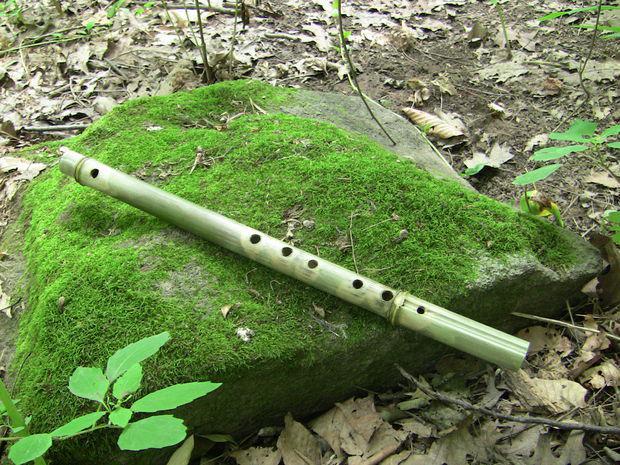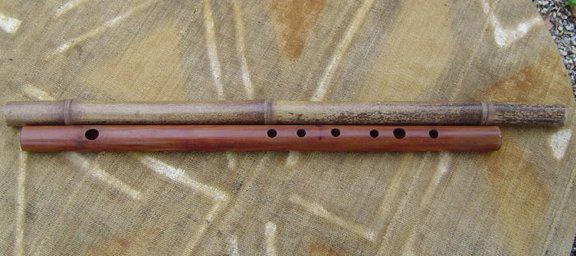The first image is the image on the left, the second image is the image on the right. Given the left and right images, does the statement "There are three flutes in total." hold true? Answer yes or no. Yes. The first image is the image on the left, the second image is the image on the right. For the images displayed, is the sentence "One image contains a single flute displayed diagonally, and the other image contains two items displayed horizontally, at least one a bamboo stick without a row of small holes on it." factually correct? Answer yes or no. Yes. 